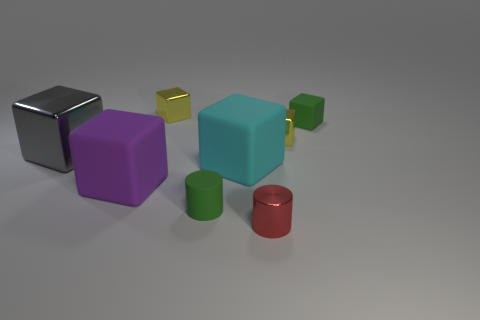What size is the purple matte thing? The purple object appears to be a cube with a matte surface finish. Its size is relatively large compared to the other objects in the scene, but without a reference for scale, it's not possible to determine its exact measurements. It is, however, the second largest cube visible in the image. 